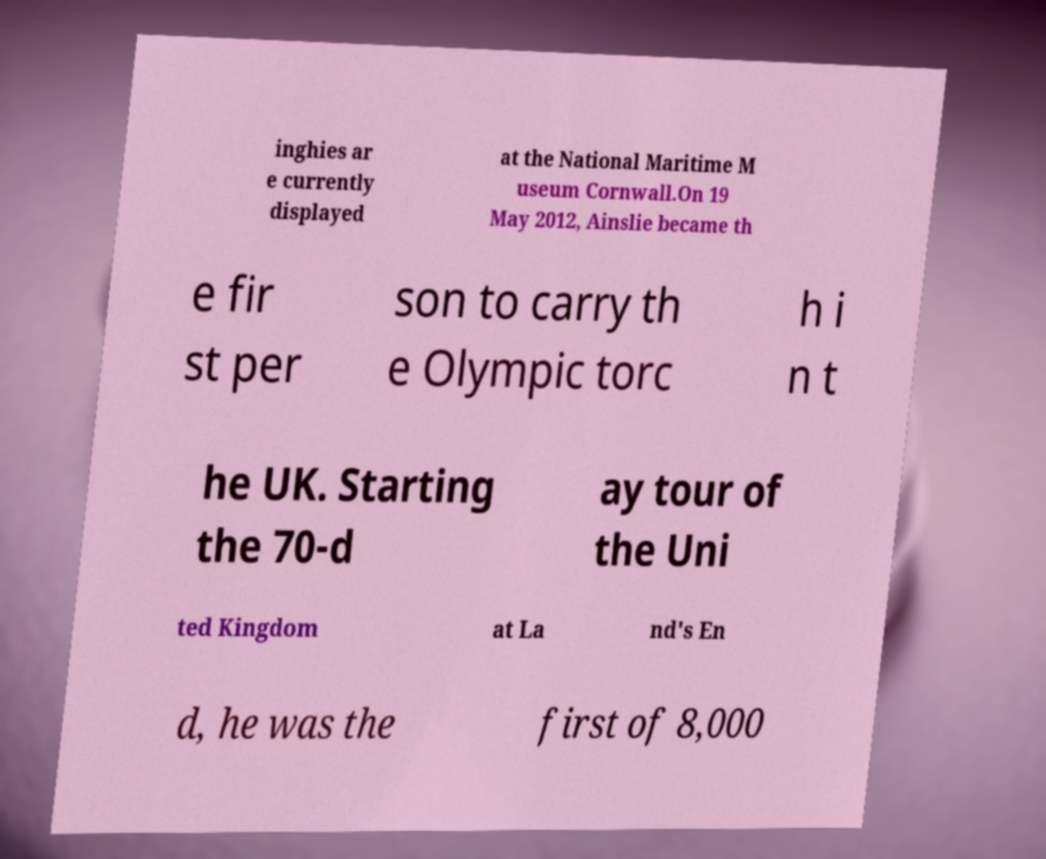I need the written content from this picture converted into text. Can you do that? inghies ar e currently displayed at the National Maritime M useum Cornwall.On 19 May 2012, Ainslie became th e fir st per son to carry th e Olympic torc h i n t he UK. Starting the 70-d ay tour of the Uni ted Kingdom at La nd's En d, he was the first of 8,000 